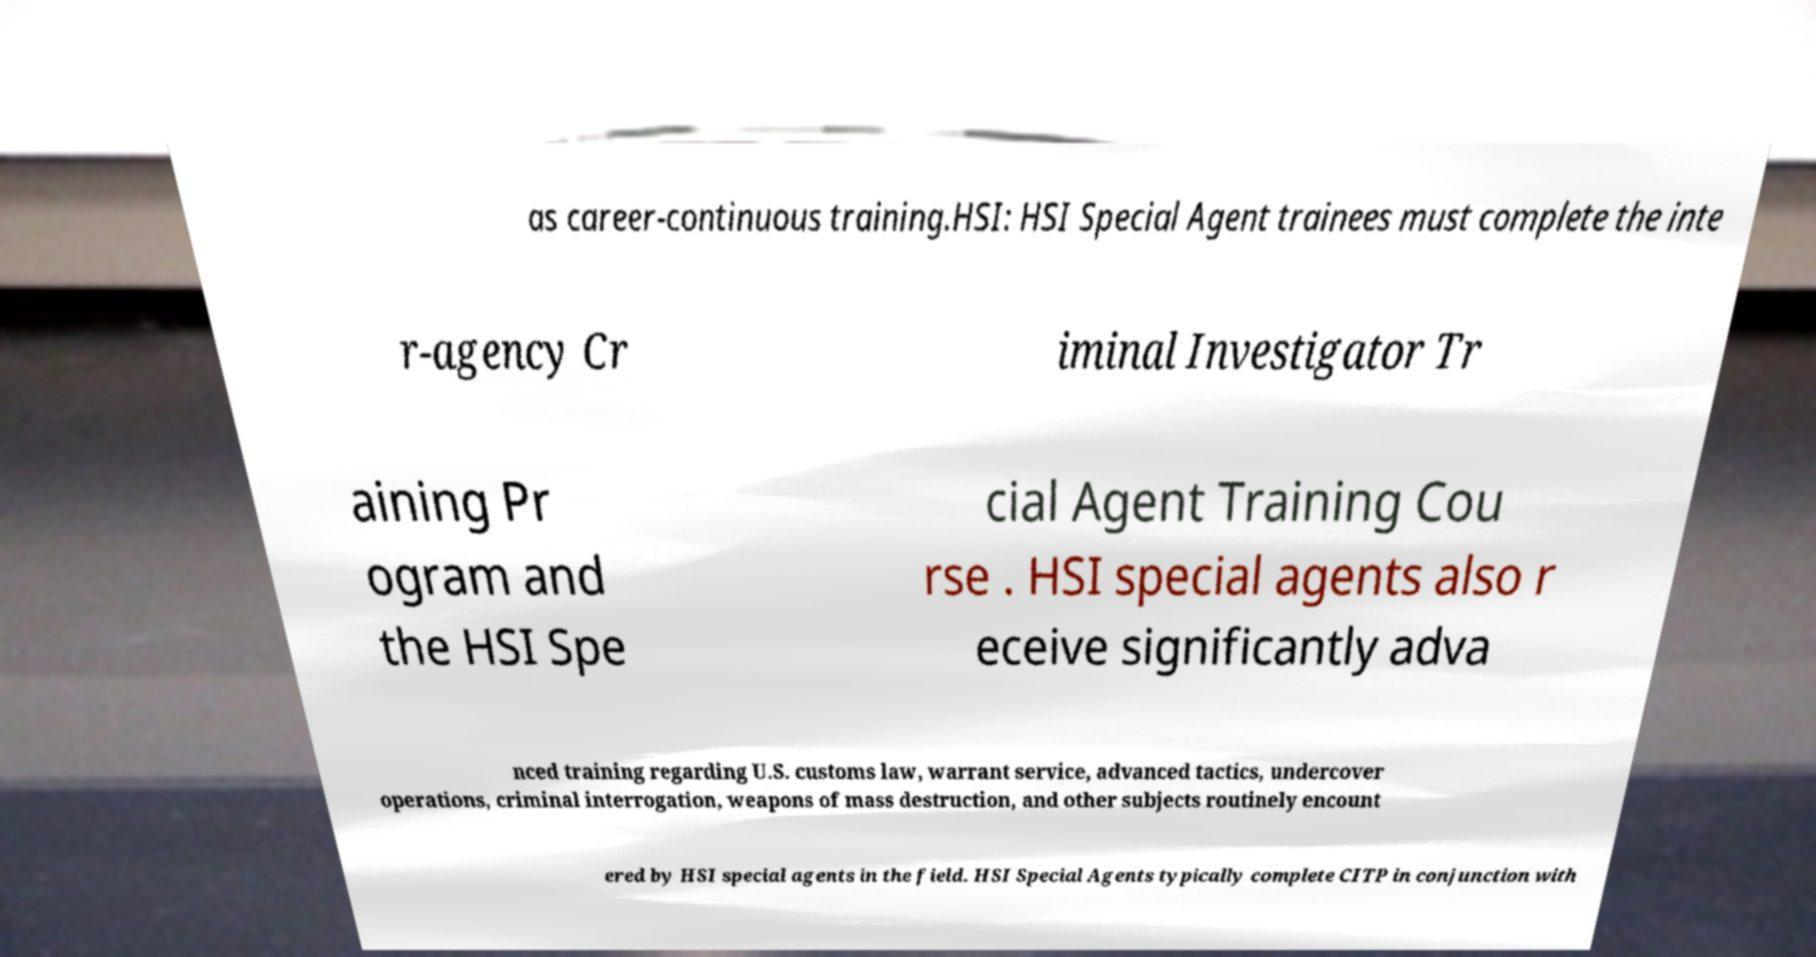Can you accurately transcribe the text from the provided image for me? as career-continuous training.HSI: HSI Special Agent trainees must complete the inte r-agency Cr iminal Investigator Tr aining Pr ogram and the HSI Spe cial Agent Training Cou rse . HSI special agents also r eceive significantly adva nced training regarding U.S. customs law, warrant service, advanced tactics, undercover operations, criminal interrogation, weapons of mass destruction, and other subjects routinely encount ered by HSI special agents in the field. HSI Special Agents typically complete CITP in conjunction with 